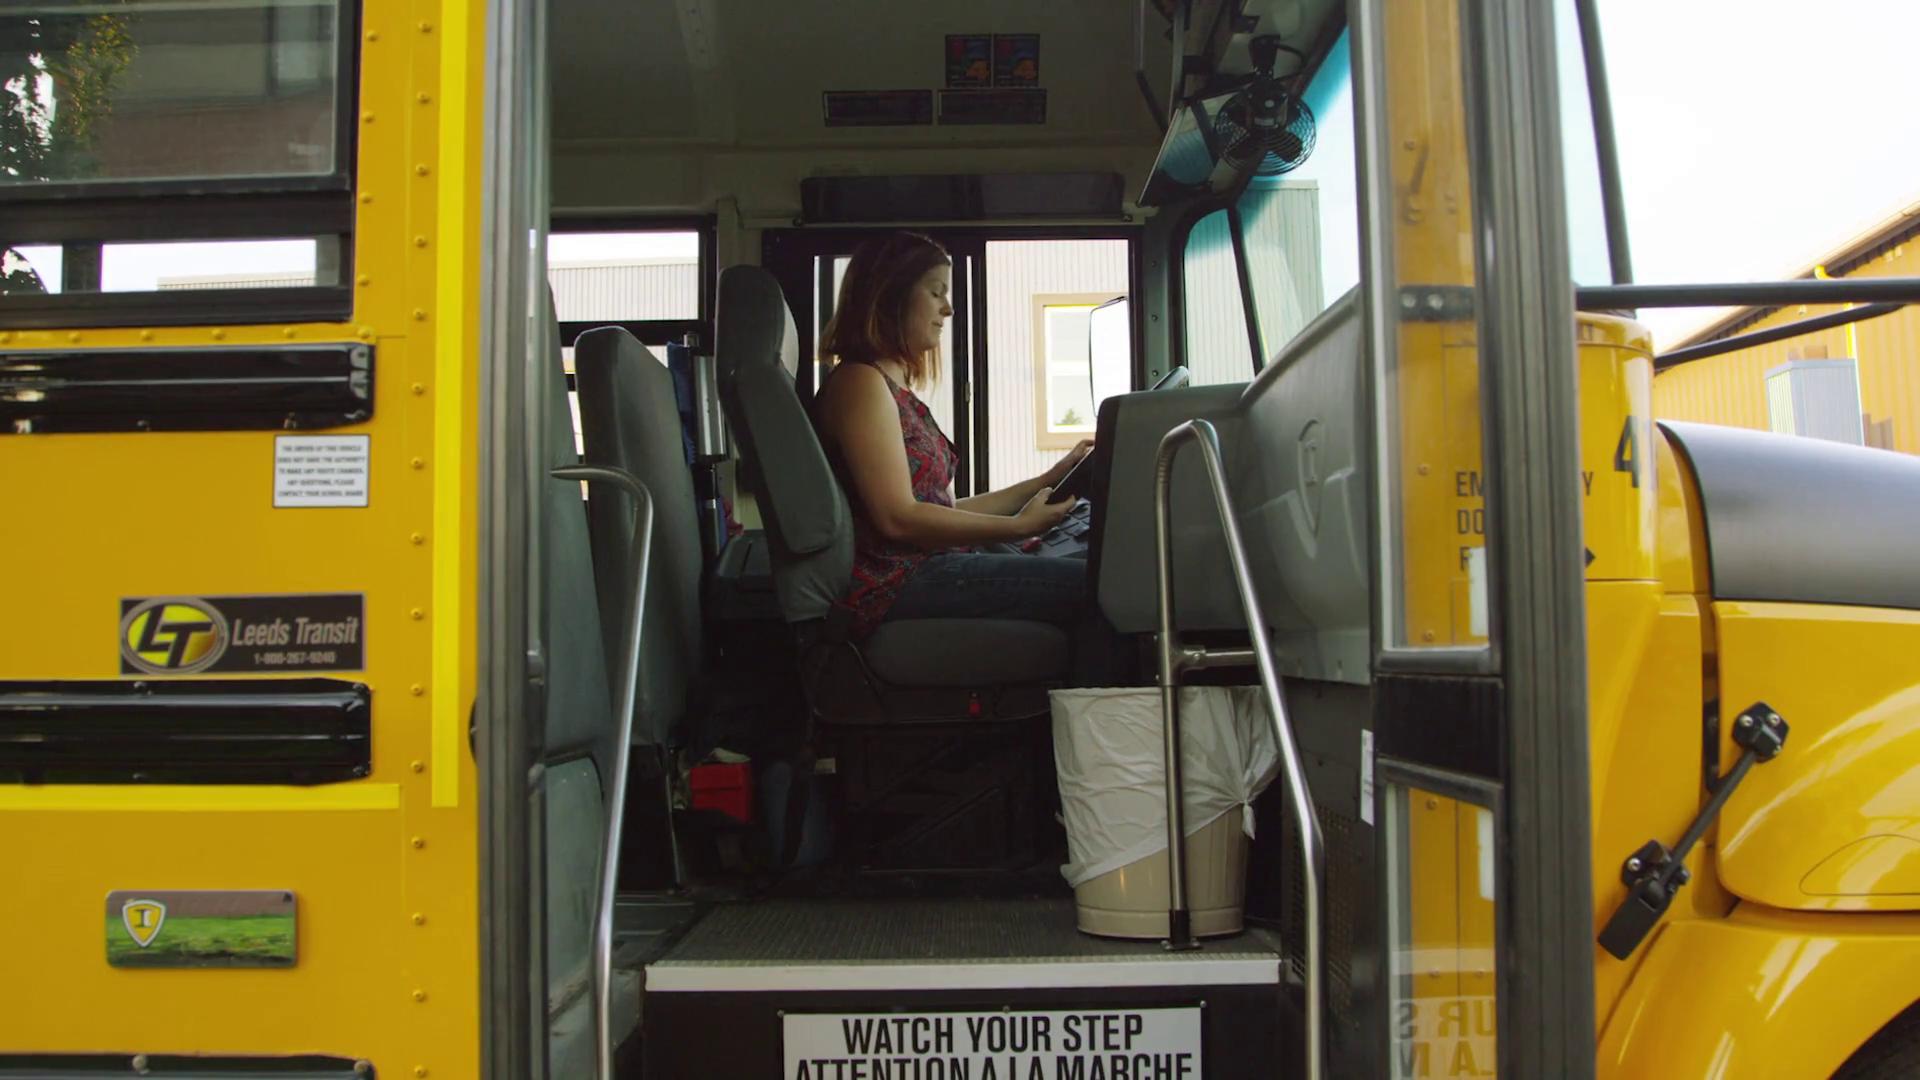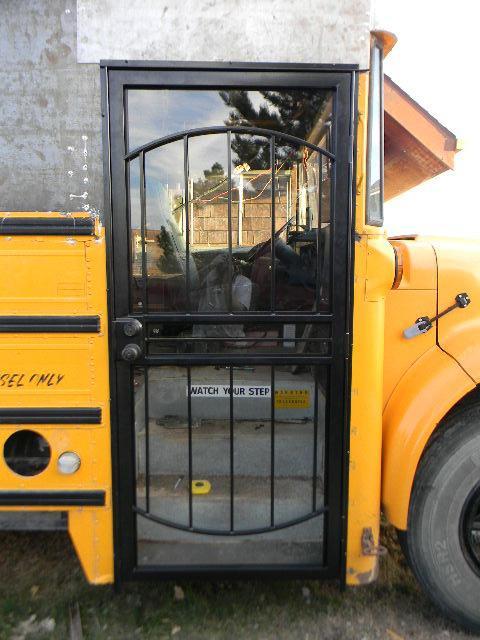The first image is the image on the left, the second image is the image on the right. Evaluate the accuracy of this statement regarding the images: "One of the buses is built with a house door.". Is it true? Answer yes or no. Yes. The first image is the image on the left, the second image is the image on the right. Given the left and right images, does the statement "The lefthand image shows a side-view of a parked yellow bus facing rightward, with its entry door opened." hold true? Answer yes or no. Yes. 